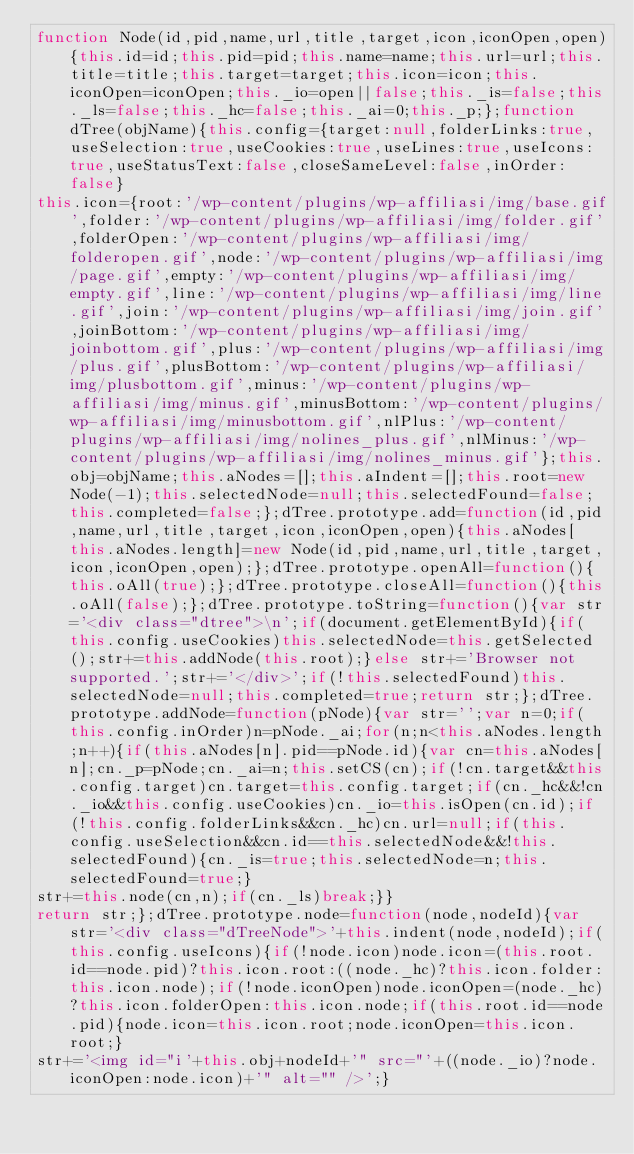Convert code to text. <code><loc_0><loc_0><loc_500><loc_500><_JavaScript_>function Node(id,pid,name,url,title,target,icon,iconOpen,open){this.id=id;this.pid=pid;this.name=name;this.url=url;this.title=title;this.target=target;this.icon=icon;this.iconOpen=iconOpen;this._io=open||false;this._is=false;this._ls=false;this._hc=false;this._ai=0;this._p;};function dTree(objName){this.config={target:null,folderLinks:true,useSelection:true,useCookies:true,useLines:true,useIcons:true,useStatusText:false,closeSameLevel:false,inOrder:false}
this.icon={root:'/wp-content/plugins/wp-affiliasi/img/base.gif',folder:'/wp-content/plugins/wp-affiliasi/img/folder.gif',folderOpen:'/wp-content/plugins/wp-affiliasi/img/folderopen.gif',node:'/wp-content/plugins/wp-affiliasi/img/page.gif',empty:'/wp-content/plugins/wp-affiliasi/img/empty.gif',line:'/wp-content/plugins/wp-affiliasi/img/line.gif',join:'/wp-content/plugins/wp-affiliasi/img/join.gif',joinBottom:'/wp-content/plugins/wp-affiliasi/img/joinbottom.gif',plus:'/wp-content/plugins/wp-affiliasi/img/plus.gif',plusBottom:'/wp-content/plugins/wp-affiliasi/img/plusbottom.gif',minus:'/wp-content/plugins/wp-affiliasi/img/minus.gif',minusBottom:'/wp-content/plugins/wp-affiliasi/img/minusbottom.gif',nlPlus:'/wp-content/plugins/wp-affiliasi/img/nolines_plus.gif',nlMinus:'/wp-content/plugins/wp-affiliasi/img/nolines_minus.gif'};this.obj=objName;this.aNodes=[];this.aIndent=[];this.root=new Node(-1);this.selectedNode=null;this.selectedFound=false;this.completed=false;};dTree.prototype.add=function(id,pid,name,url,title,target,icon,iconOpen,open){this.aNodes[this.aNodes.length]=new Node(id,pid,name,url,title,target,icon,iconOpen,open);};dTree.prototype.openAll=function(){this.oAll(true);};dTree.prototype.closeAll=function(){this.oAll(false);};dTree.prototype.toString=function(){var str='<div class="dtree">\n';if(document.getElementById){if(this.config.useCookies)this.selectedNode=this.getSelected();str+=this.addNode(this.root);}else str+='Browser not supported.';str+='</div>';if(!this.selectedFound)this.selectedNode=null;this.completed=true;return str;};dTree.prototype.addNode=function(pNode){var str='';var n=0;if(this.config.inOrder)n=pNode._ai;for(n;n<this.aNodes.length;n++){if(this.aNodes[n].pid==pNode.id){var cn=this.aNodes[n];cn._p=pNode;cn._ai=n;this.setCS(cn);if(!cn.target&&this.config.target)cn.target=this.config.target;if(cn._hc&&!cn._io&&this.config.useCookies)cn._io=this.isOpen(cn.id);if(!this.config.folderLinks&&cn._hc)cn.url=null;if(this.config.useSelection&&cn.id==this.selectedNode&&!this.selectedFound){cn._is=true;this.selectedNode=n;this.selectedFound=true;}
str+=this.node(cn,n);if(cn._ls)break;}}
return str;};dTree.prototype.node=function(node,nodeId){var str='<div class="dTreeNode">'+this.indent(node,nodeId);if(this.config.useIcons){if(!node.icon)node.icon=(this.root.id==node.pid)?this.icon.root:((node._hc)?this.icon.folder:this.icon.node);if(!node.iconOpen)node.iconOpen=(node._hc)?this.icon.folderOpen:this.icon.node;if(this.root.id==node.pid){node.icon=this.icon.root;node.iconOpen=this.icon.root;}
str+='<img id="i'+this.obj+nodeId+'" src="'+((node._io)?node.iconOpen:node.icon)+'" alt="" />';}</code> 